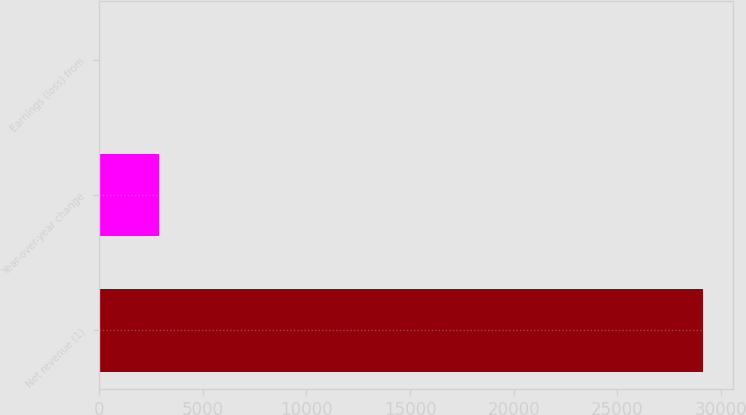Convert chart to OTSL. <chart><loc_0><loc_0><loc_500><loc_500><bar_chart><fcel>Net revenue (1)<fcel>Year-over-year change<fcel>Earnings (loss) from<nl><fcel>29135<fcel>2917.46<fcel>4.4<nl></chart> 